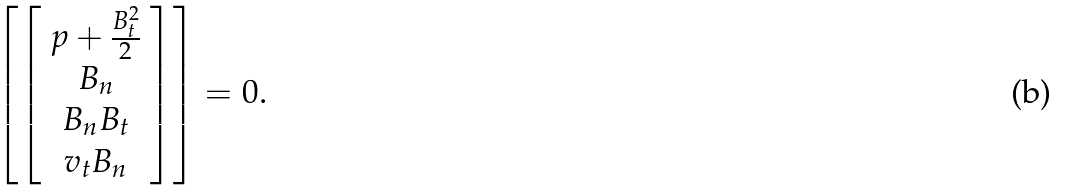Convert formula to latex. <formula><loc_0><loc_0><loc_500><loc_500>\left [ \left [ \begin{array} { c } p + \frac { B _ { t } ^ { 2 } } { 2 } \\ B _ { n } \\ B _ { n } B _ { t } \\ v _ { t } B _ { n } \\ \end{array} \right ] \right ] = 0 .</formula> 